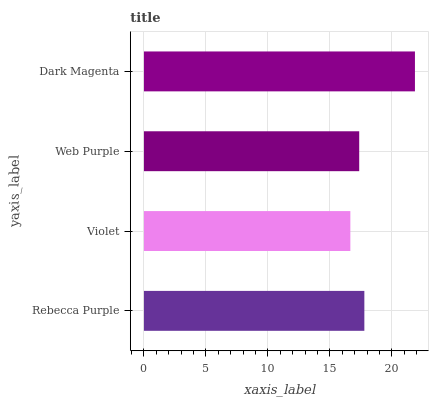Is Violet the minimum?
Answer yes or no. Yes. Is Dark Magenta the maximum?
Answer yes or no. Yes. Is Web Purple the minimum?
Answer yes or no. No. Is Web Purple the maximum?
Answer yes or no. No. Is Web Purple greater than Violet?
Answer yes or no. Yes. Is Violet less than Web Purple?
Answer yes or no. Yes. Is Violet greater than Web Purple?
Answer yes or no. No. Is Web Purple less than Violet?
Answer yes or no. No. Is Rebecca Purple the high median?
Answer yes or no. Yes. Is Web Purple the low median?
Answer yes or no. Yes. Is Dark Magenta the high median?
Answer yes or no. No. Is Dark Magenta the low median?
Answer yes or no. No. 